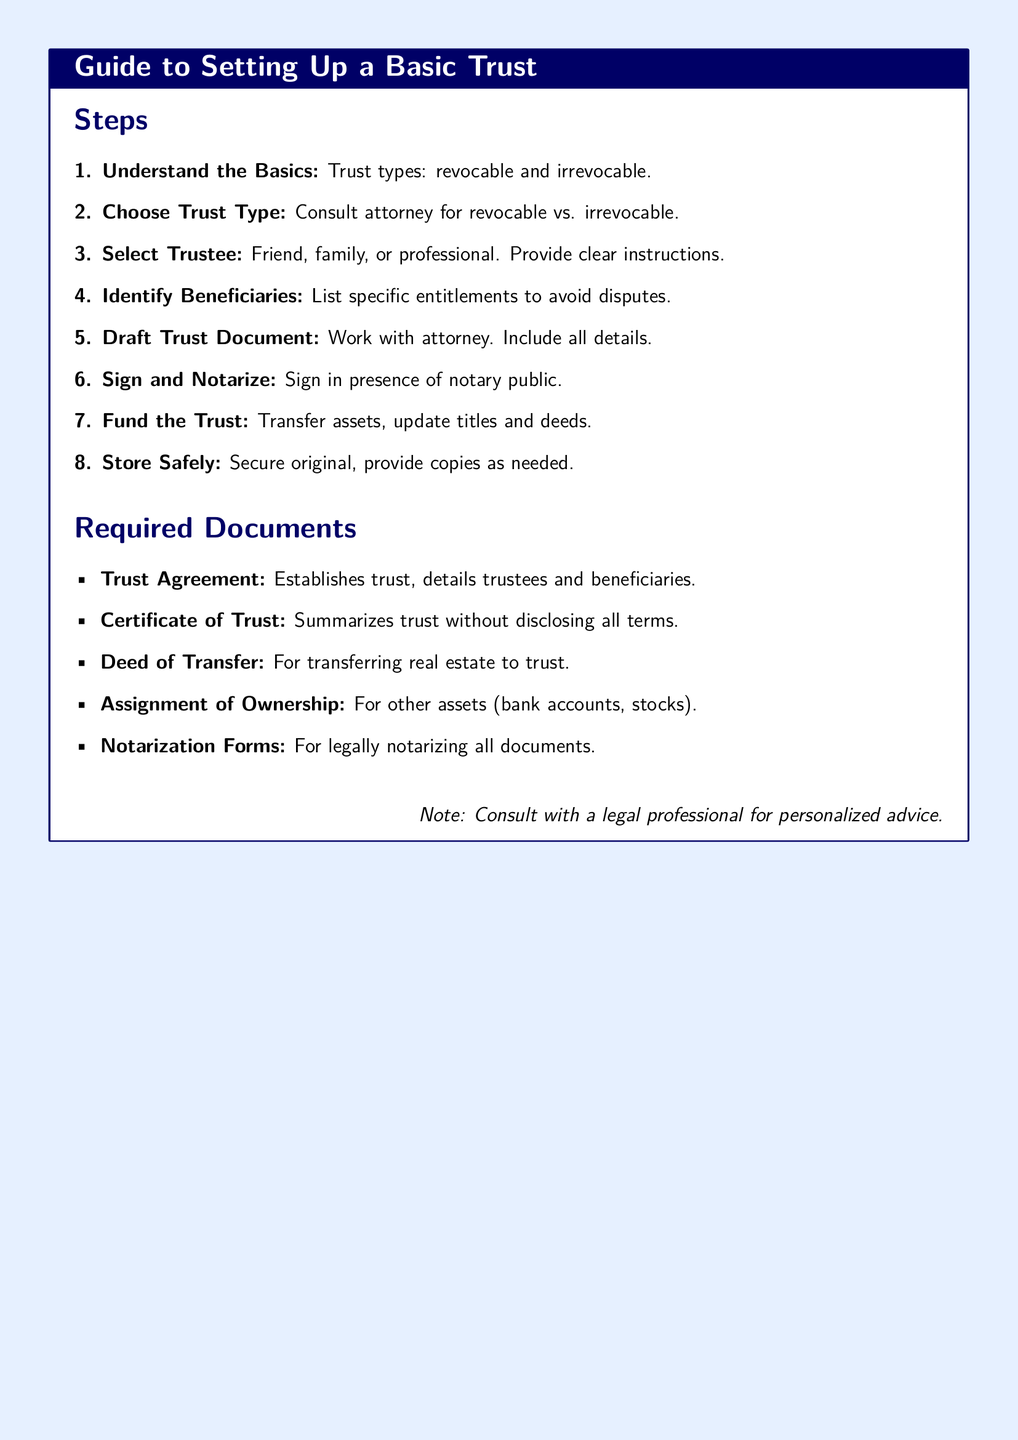What is the first step in setting up a trust? The first step listed in the document is to understand the basics of trust types, which include revocable and irrevocable.
Answer: Understand the Basics What type of trust should one consult an attorney about? The document mentions consulting an attorney regarding revocable vs. irrevocable trust types.
Answer: Revocable vs. Irrevocable Who can be selected as a trustee? The document states that the trustee can be a friend, family member, or professional.
Answer: Friend, family, or professional What is a required document that summarizes the trust without disclosing all terms? The document specifies the Certificate of Trust as a required document that summarizes the trust.
Answer: Certificate of Trust What must be done after drafting the trust document? According to the document, the next step after drafting the trust document is to sign and notarize it.
Answer: Sign and Notarize How many major steps are outlined in the document for setting up a basic trust? The document outlines a total of eight major steps for setting up a trust.
Answer: Eight What is one action needed to fund the trust? The document lists transferring assets as one necessary action for funding the trust.
Answer: Transfer assets What is a note given in the document? The document includes a note advising to consult with a legal professional for personalized advice.
Answer: Consult with a legal professional 